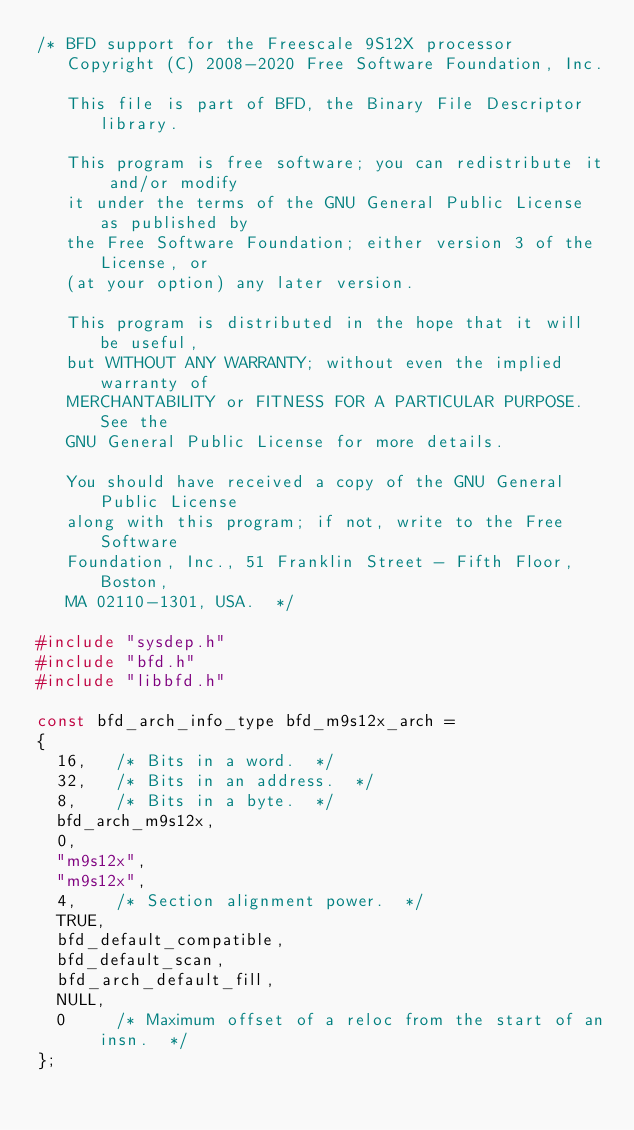Convert code to text. <code><loc_0><loc_0><loc_500><loc_500><_C_>/* BFD support for the Freescale 9S12X processor
   Copyright (C) 2008-2020 Free Software Foundation, Inc.

   This file is part of BFD, the Binary File Descriptor library.

   This program is free software; you can redistribute it and/or modify
   it under the terms of the GNU General Public License as published by
   the Free Software Foundation; either version 3 of the License, or
   (at your option) any later version.

   This program is distributed in the hope that it will be useful,
   but WITHOUT ANY WARRANTY; without even the implied warranty of
   MERCHANTABILITY or FITNESS FOR A PARTICULAR PURPOSE.  See the
   GNU General Public License for more details.

   You should have received a copy of the GNU General Public License
   along with this program; if not, write to the Free Software
   Foundation, Inc., 51 Franklin Street - Fifth Floor, Boston,
   MA 02110-1301, USA.  */

#include "sysdep.h"
#include "bfd.h"
#include "libbfd.h"

const bfd_arch_info_type bfd_m9s12x_arch =
{
  16,	/* Bits in a word.  */
  32,	/* Bits in an address.  */
  8,	/* Bits in a byte.  */
  bfd_arch_m9s12x,
  0,
  "m9s12x",
  "m9s12x",
  4,    /* Section alignment power.  */
  TRUE,
  bfd_default_compatible,
  bfd_default_scan,
  bfd_arch_default_fill,
  NULL,
  0     /* Maximum offset of a reloc from the start of an insn.  */
};

</code> 